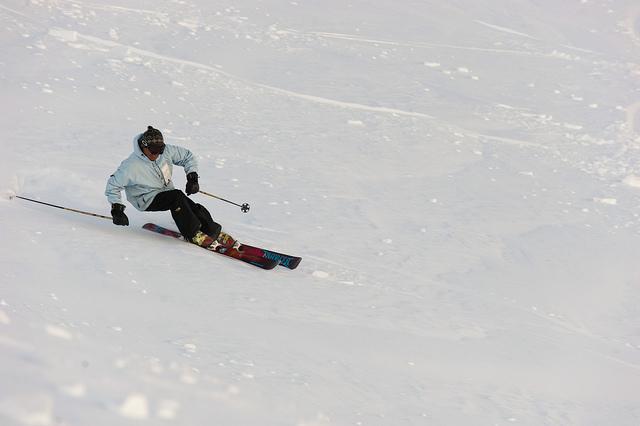What color are the stripes on his board?
Concise answer only. Red. What color are the kids shoes?
Be succinct. Red. What is on the ground?
Write a very short answer. Snow. What is the person holding in their hands?
Keep it brief. Poles. Which direction is the skier leaning?
Give a very brief answer. Right. What sport is shown?
Quick response, please. Skiing. What is this person doing?
Quick response, please. Skiing. 